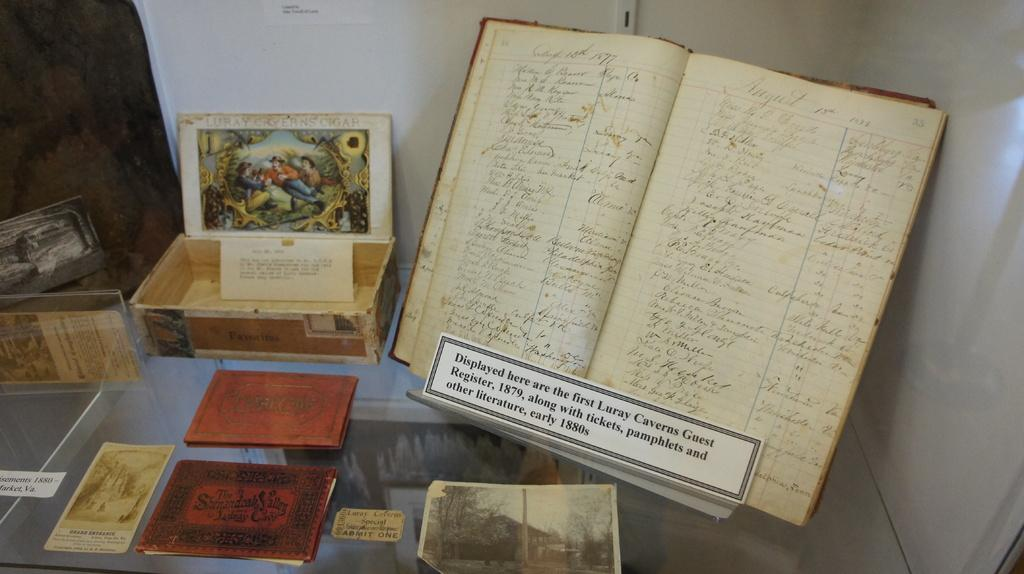What is the main object in the image? There is a register book in the image. What else can be seen in the image besides the register book? There is a box and papers visible in the image. Can you describe the other unspecified objects on a surface? Unfortunately, the facts do not specify what these objects are, so we cannot describe them. What is visible in the background of the image? There is a wall in the background of the image. What type of rod is being used to control the impulse of the bit in the image? There is no rod, impulse, or bit present in the image. 